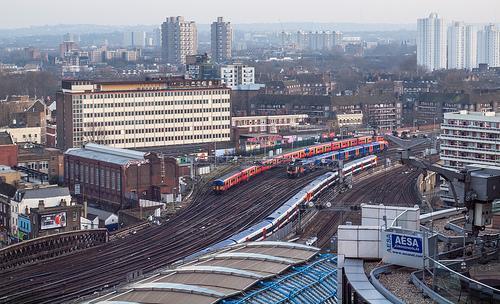How many trains are there?
Give a very brief answer. 2. 